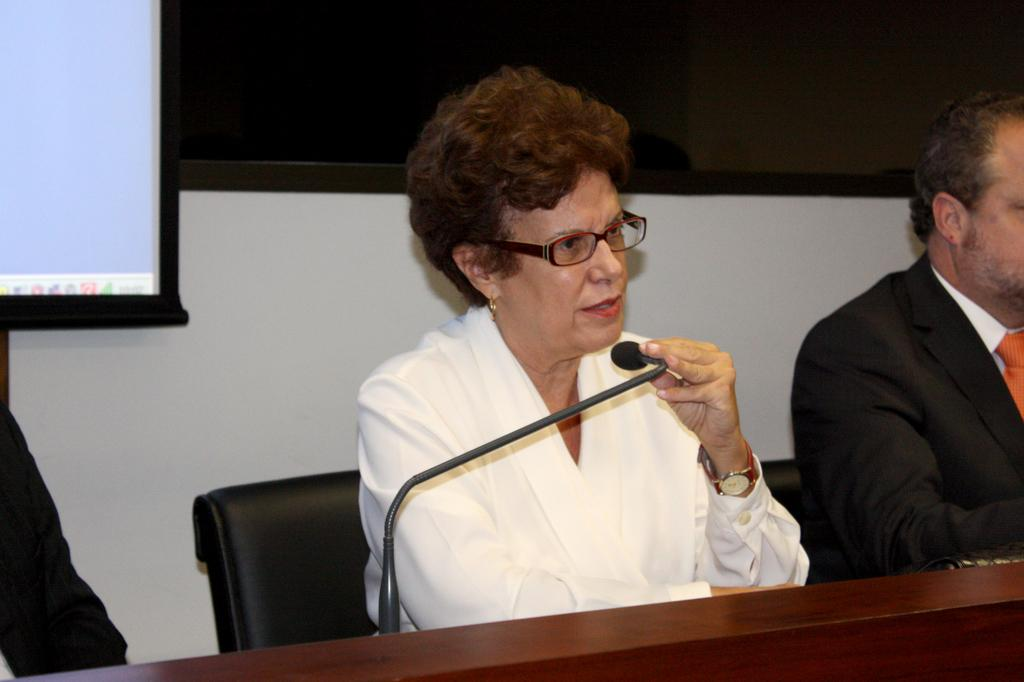Who is the main subject in the image? There is a woman in the image. What is the woman doing in the image? The woman is sitting on a chair and holding a microphone. Are there any other people in the image? Yes, there are people sitting nearby. What can be seen on the wall in the background? There is a board on the wall in the background. What type of parcel is being delivered to the woman in the image? There is no parcel being delivered to the woman in the image. What activity is happening in downtown in the image? The image does not depict a downtown location or any specific activity. 